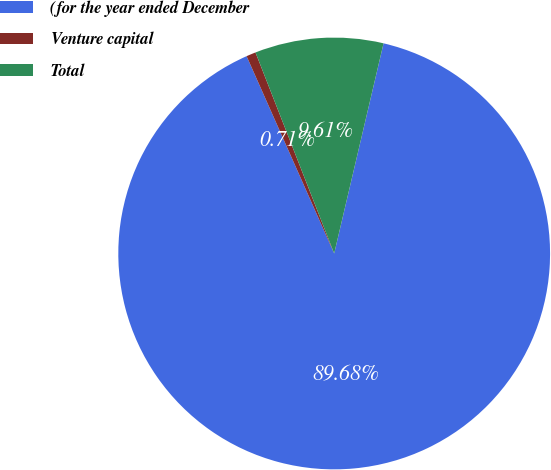Convert chart. <chart><loc_0><loc_0><loc_500><loc_500><pie_chart><fcel>(for the year ended December<fcel>Venture capital<fcel>Total<nl><fcel>89.67%<fcel>0.71%<fcel>9.61%<nl></chart> 